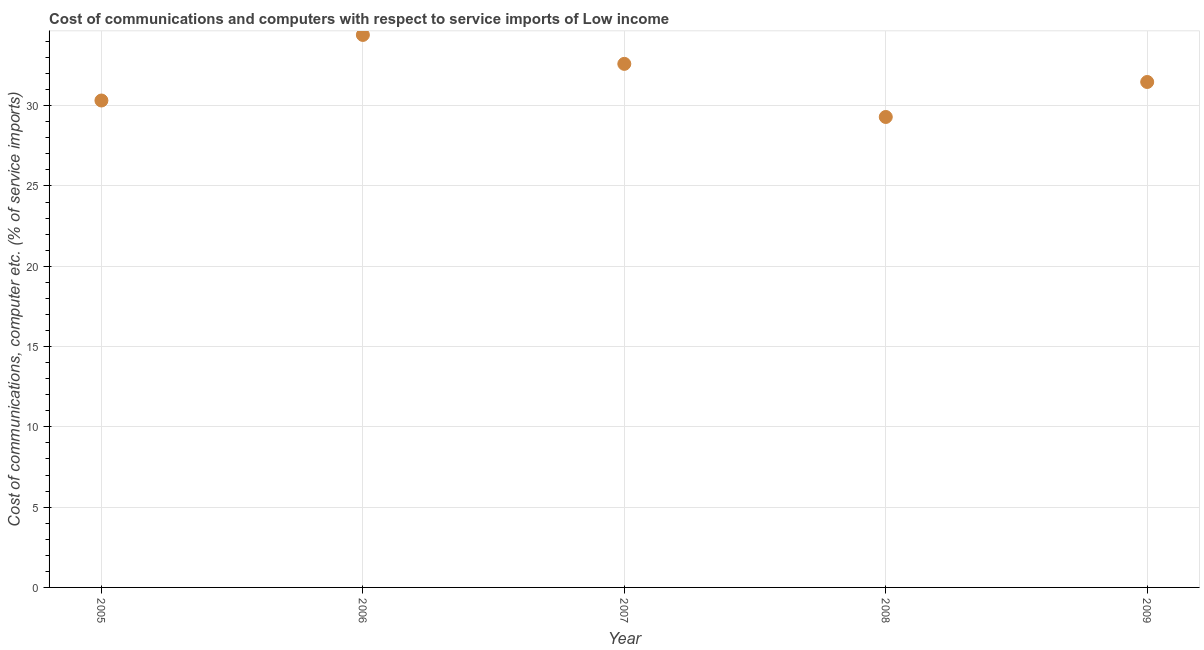What is the cost of communications and computer in 2009?
Keep it short and to the point. 31.48. Across all years, what is the maximum cost of communications and computer?
Make the answer very short. 34.41. Across all years, what is the minimum cost of communications and computer?
Provide a short and direct response. 29.3. In which year was the cost of communications and computer minimum?
Give a very brief answer. 2008. What is the sum of the cost of communications and computer?
Your answer should be very brief. 158.1. What is the difference between the cost of communications and computer in 2006 and 2009?
Your answer should be very brief. 2.93. What is the average cost of communications and computer per year?
Provide a succinct answer. 31.62. What is the median cost of communications and computer?
Make the answer very short. 31.48. In how many years, is the cost of communications and computer greater than 5 %?
Give a very brief answer. 5. Do a majority of the years between 2005 and 2007 (inclusive) have cost of communications and computer greater than 8 %?
Make the answer very short. Yes. What is the ratio of the cost of communications and computer in 2005 to that in 2007?
Keep it short and to the point. 0.93. Is the cost of communications and computer in 2005 less than that in 2008?
Your response must be concise. No. What is the difference between the highest and the second highest cost of communications and computer?
Offer a terse response. 1.8. Is the sum of the cost of communications and computer in 2005 and 2008 greater than the maximum cost of communications and computer across all years?
Ensure brevity in your answer.  Yes. What is the difference between the highest and the lowest cost of communications and computer?
Your answer should be very brief. 5.11. In how many years, is the cost of communications and computer greater than the average cost of communications and computer taken over all years?
Give a very brief answer. 2. How many dotlines are there?
Make the answer very short. 1. How many years are there in the graph?
Keep it short and to the point. 5. Are the values on the major ticks of Y-axis written in scientific E-notation?
Give a very brief answer. No. Does the graph contain any zero values?
Provide a succinct answer. No. What is the title of the graph?
Your answer should be compact. Cost of communications and computers with respect to service imports of Low income. What is the label or title of the Y-axis?
Give a very brief answer. Cost of communications, computer etc. (% of service imports). What is the Cost of communications, computer etc. (% of service imports) in 2005?
Your answer should be compact. 30.32. What is the Cost of communications, computer etc. (% of service imports) in 2006?
Give a very brief answer. 34.41. What is the Cost of communications, computer etc. (% of service imports) in 2007?
Ensure brevity in your answer.  32.6. What is the Cost of communications, computer etc. (% of service imports) in 2008?
Ensure brevity in your answer.  29.3. What is the Cost of communications, computer etc. (% of service imports) in 2009?
Provide a short and direct response. 31.48. What is the difference between the Cost of communications, computer etc. (% of service imports) in 2005 and 2006?
Provide a succinct answer. -4.08. What is the difference between the Cost of communications, computer etc. (% of service imports) in 2005 and 2007?
Keep it short and to the point. -2.28. What is the difference between the Cost of communications, computer etc. (% of service imports) in 2005 and 2008?
Ensure brevity in your answer.  1.03. What is the difference between the Cost of communications, computer etc. (% of service imports) in 2005 and 2009?
Make the answer very short. -1.15. What is the difference between the Cost of communications, computer etc. (% of service imports) in 2006 and 2007?
Your answer should be compact. 1.8. What is the difference between the Cost of communications, computer etc. (% of service imports) in 2006 and 2008?
Your answer should be very brief. 5.11. What is the difference between the Cost of communications, computer etc. (% of service imports) in 2006 and 2009?
Ensure brevity in your answer.  2.93. What is the difference between the Cost of communications, computer etc. (% of service imports) in 2007 and 2008?
Give a very brief answer. 3.31. What is the difference between the Cost of communications, computer etc. (% of service imports) in 2007 and 2009?
Provide a short and direct response. 1.13. What is the difference between the Cost of communications, computer etc. (% of service imports) in 2008 and 2009?
Offer a terse response. -2.18. What is the ratio of the Cost of communications, computer etc. (% of service imports) in 2005 to that in 2006?
Your response must be concise. 0.88. What is the ratio of the Cost of communications, computer etc. (% of service imports) in 2005 to that in 2007?
Your response must be concise. 0.93. What is the ratio of the Cost of communications, computer etc. (% of service imports) in 2005 to that in 2008?
Offer a very short reply. 1.03. What is the ratio of the Cost of communications, computer etc. (% of service imports) in 2005 to that in 2009?
Ensure brevity in your answer.  0.96. What is the ratio of the Cost of communications, computer etc. (% of service imports) in 2006 to that in 2007?
Give a very brief answer. 1.05. What is the ratio of the Cost of communications, computer etc. (% of service imports) in 2006 to that in 2008?
Your answer should be compact. 1.17. What is the ratio of the Cost of communications, computer etc. (% of service imports) in 2006 to that in 2009?
Make the answer very short. 1.09. What is the ratio of the Cost of communications, computer etc. (% of service imports) in 2007 to that in 2008?
Keep it short and to the point. 1.11. What is the ratio of the Cost of communications, computer etc. (% of service imports) in 2007 to that in 2009?
Provide a short and direct response. 1.04. What is the ratio of the Cost of communications, computer etc. (% of service imports) in 2008 to that in 2009?
Provide a succinct answer. 0.93. 